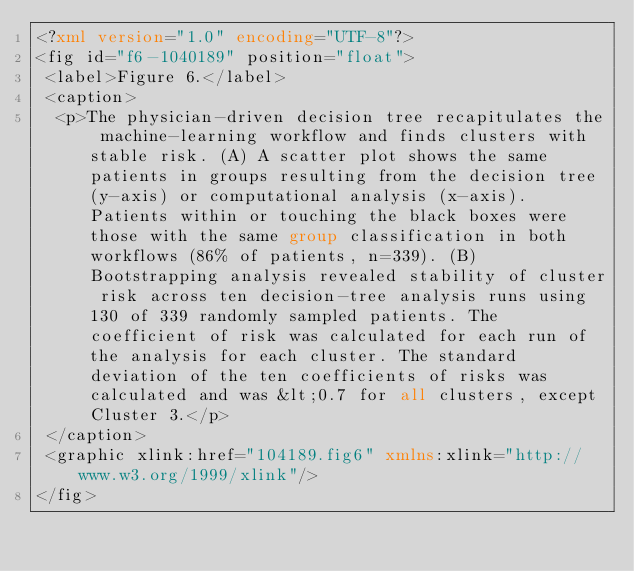<code> <loc_0><loc_0><loc_500><loc_500><_XML_><?xml version="1.0" encoding="UTF-8"?>
<fig id="f6-1040189" position="float">
 <label>Figure 6.</label>
 <caption>
  <p>The physician-driven decision tree recapitulates the machine-learning workflow and finds clusters with stable risk. (A) A scatter plot shows the same patients in groups resulting from the decision tree (y-axis) or computational analysis (x-axis). Patients within or touching the black boxes were those with the same group classification in both workflows (86% of patients, n=339). (B) Bootstrapping analysis revealed stability of cluster risk across ten decision-tree analysis runs using 130 of 339 randomly sampled patients. The coefficient of risk was calculated for each run of the analysis for each cluster. The standard deviation of the ten coefficients of risks was calculated and was &lt;0.7 for all clusters, except Cluster 3.</p>
 </caption>
 <graphic xlink:href="104189.fig6" xmlns:xlink="http://www.w3.org/1999/xlink"/>
</fig>
</code> 